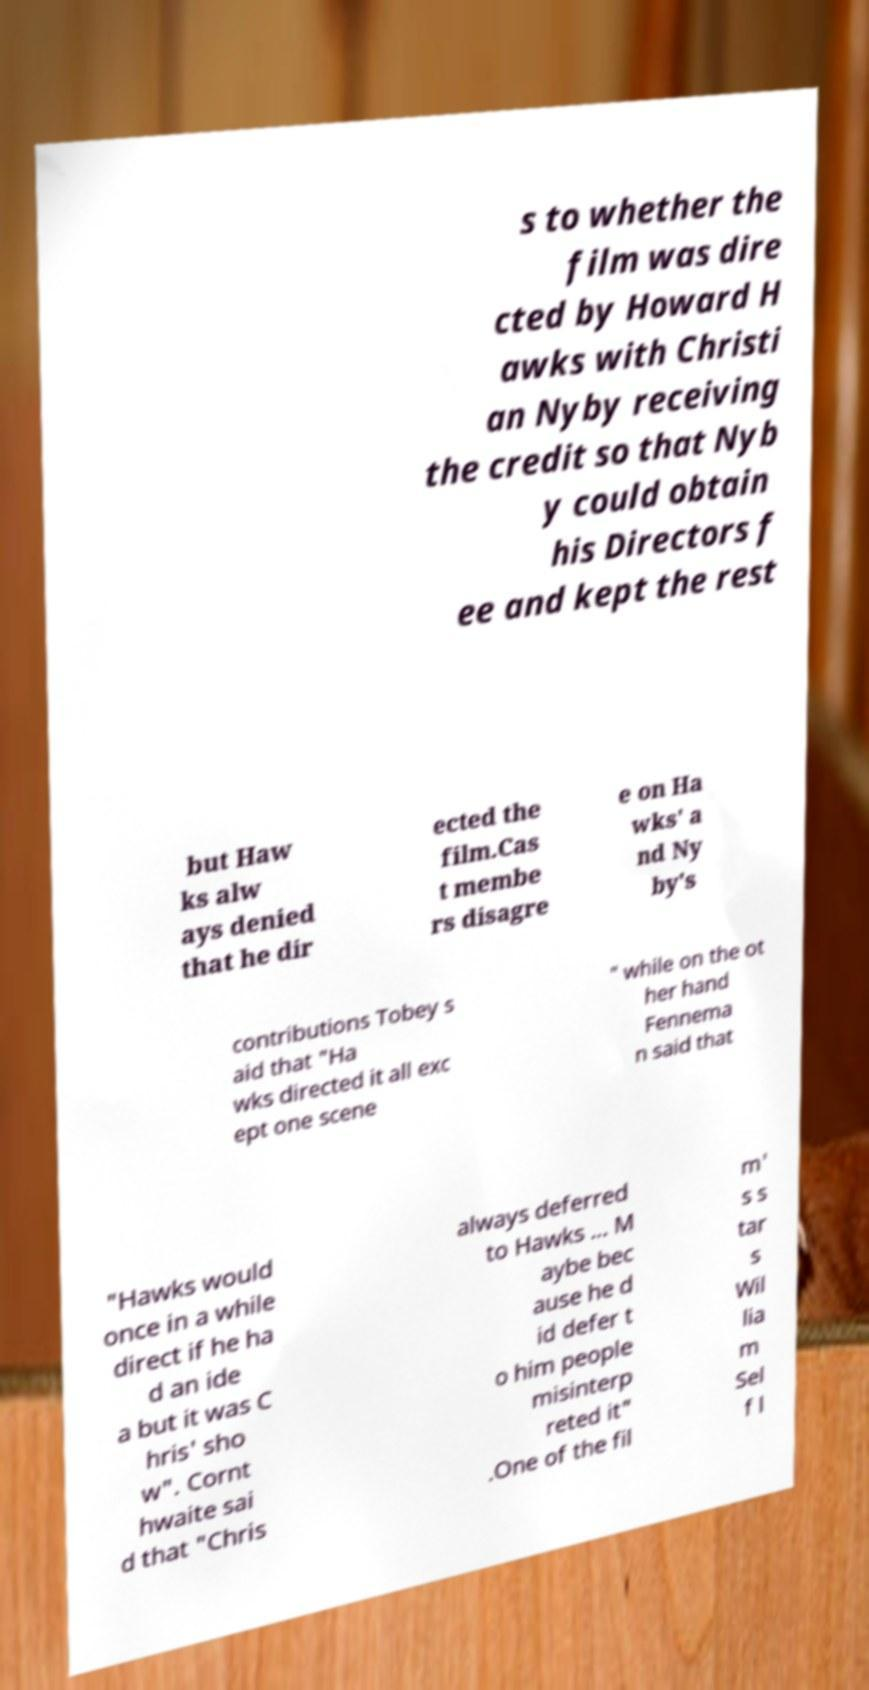Can you accurately transcribe the text from the provided image for me? s to whether the film was dire cted by Howard H awks with Christi an Nyby receiving the credit so that Nyb y could obtain his Directors f ee and kept the rest but Haw ks alw ays denied that he dir ected the film.Cas t membe rs disagre e on Ha wks' a nd Ny by's contributions Tobey s aid that "Ha wks directed it all exc ept one scene " while on the ot her hand Fennema n said that "Hawks would once in a while direct if he ha d an ide a but it was C hris' sho w". Cornt hwaite sai d that "Chris always deferred to Hawks ... M aybe bec ause he d id defer t o him people misinterp reted it" .One of the fil m' s s tar s Wil lia m Sel f l 